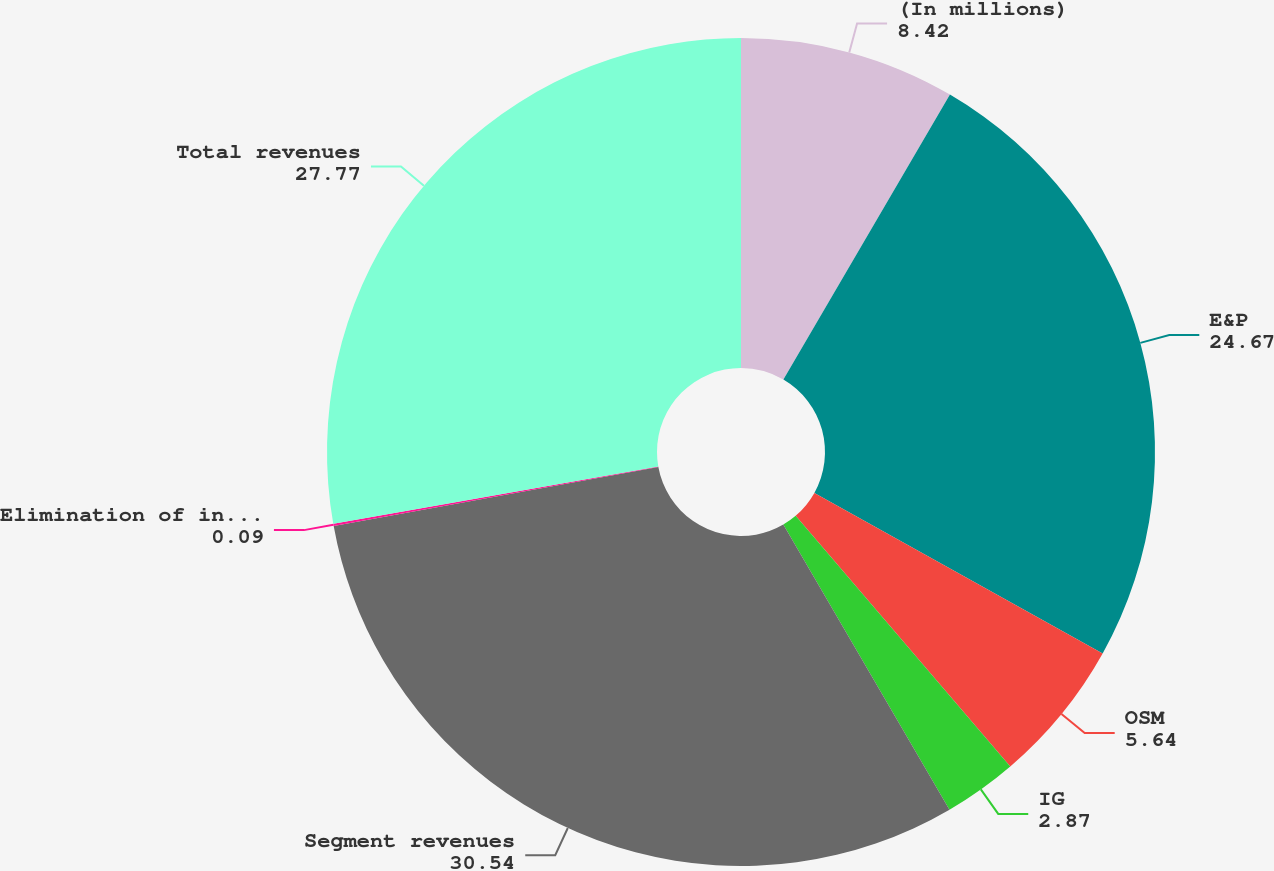<chart> <loc_0><loc_0><loc_500><loc_500><pie_chart><fcel>(In millions)<fcel>E&P<fcel>OSM<fcel>IG<fcel>Segment revenues<fcel>Elimination of intersegment<fcel>Total revenues<nl><fcel>8.42%<fcel>24.67%<fcel>5.64%<fcel>2.87%<fcel>30.54%<fcel>0.09%<fcel>27.77%<nl></chart> 